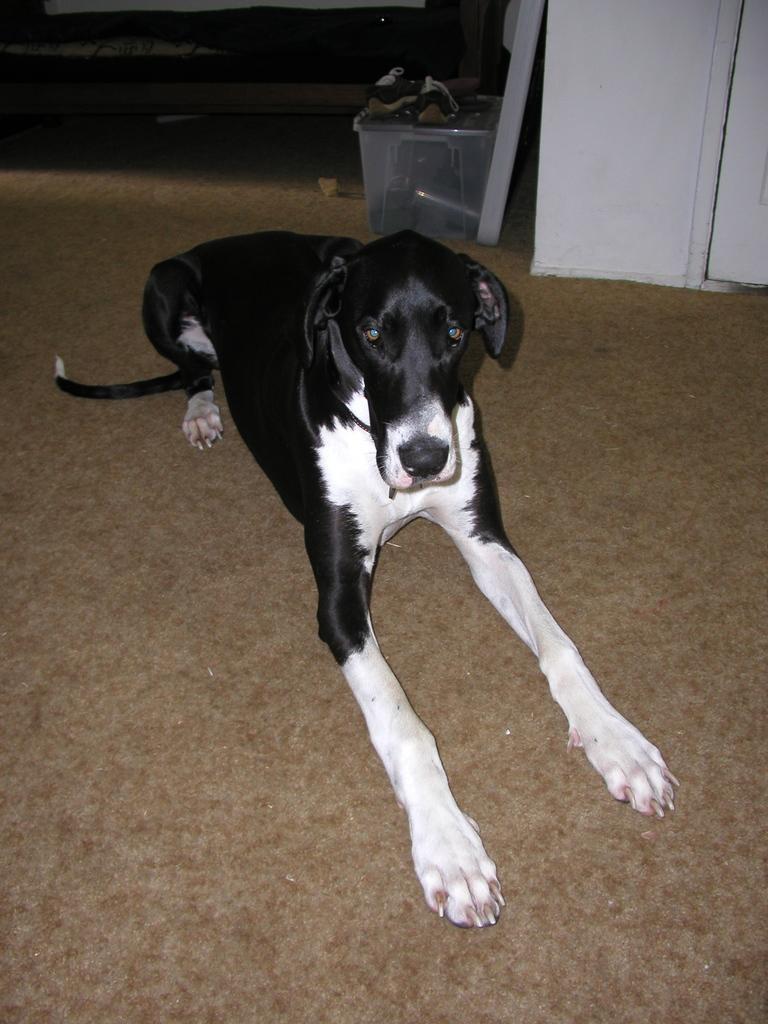Could you give a brief overview of what you see in this image? In this picture we can see a dog on the floor and in the background we can see a box, wall and some objects. 